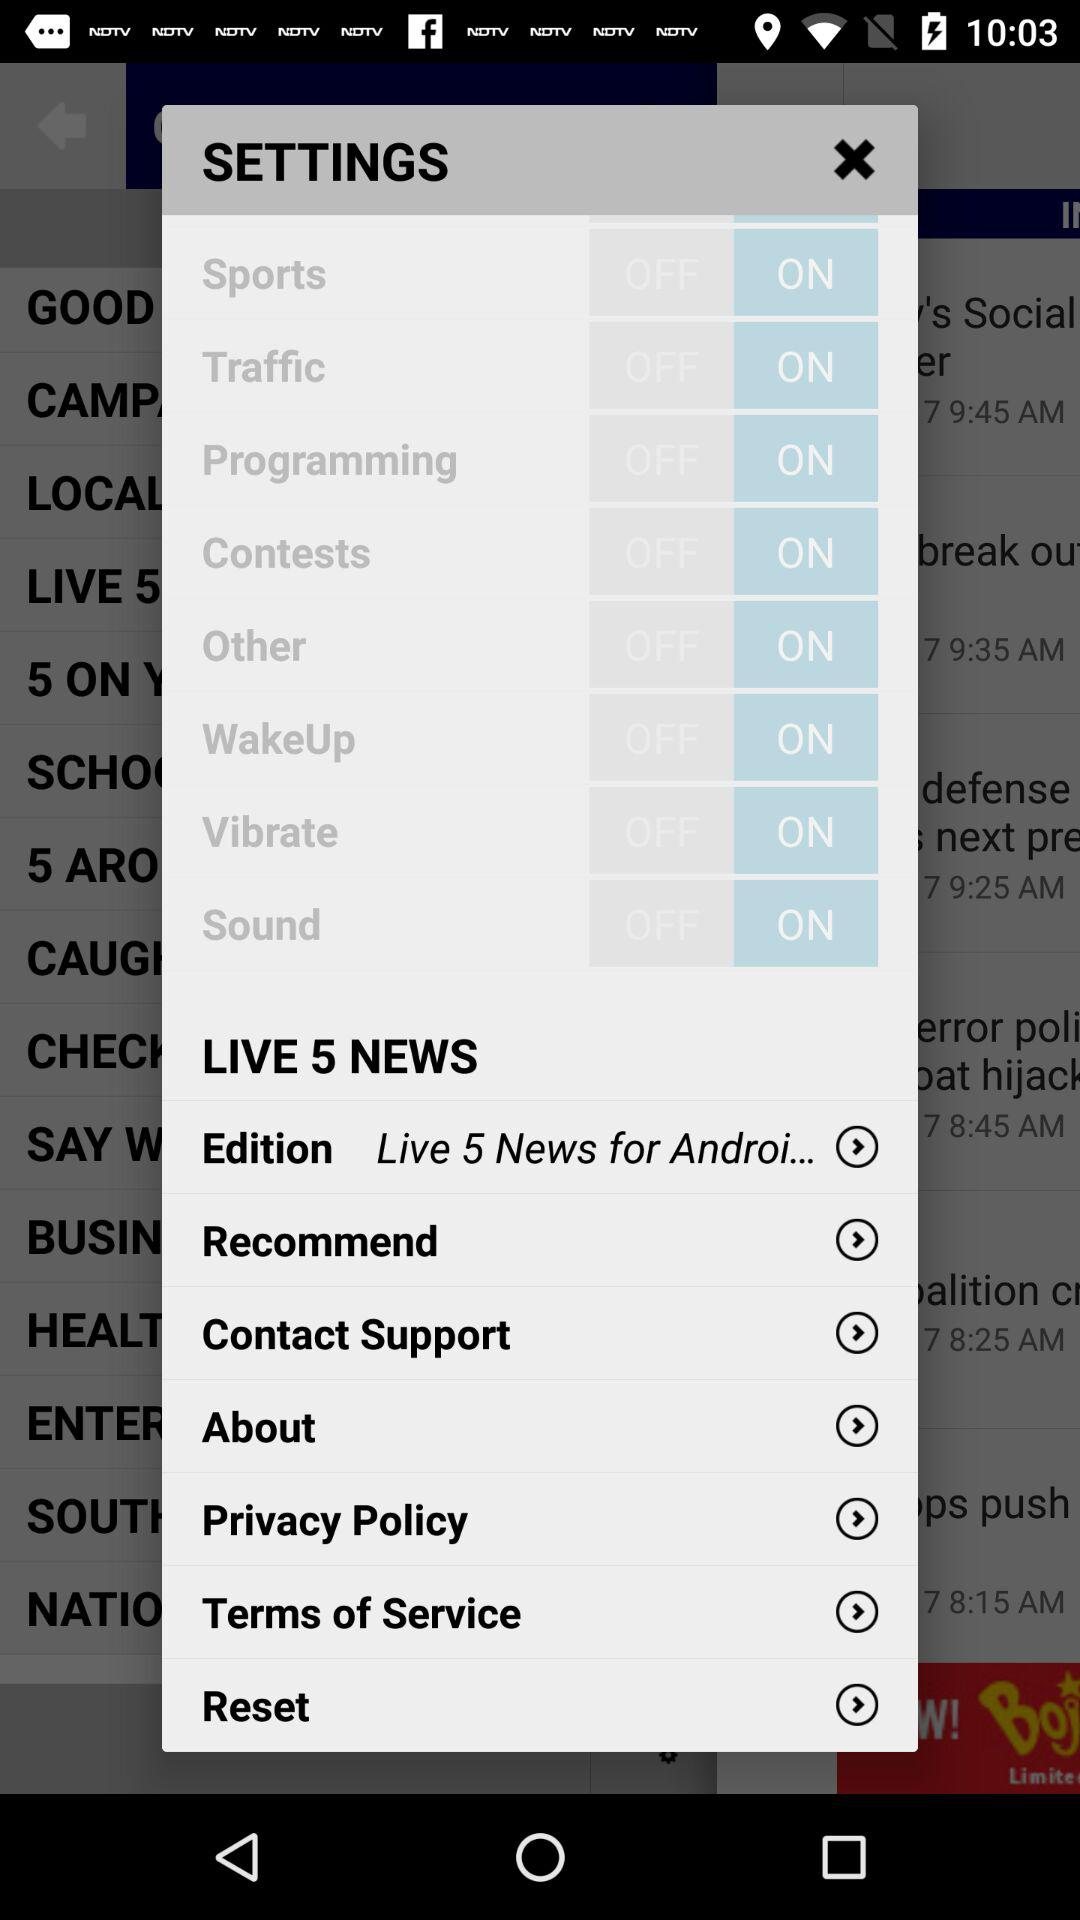What is the edition of "LIVE 5 NEWS"? The edition of "LIVE 5 NEWS" is "Live 5 News for Androi...". 